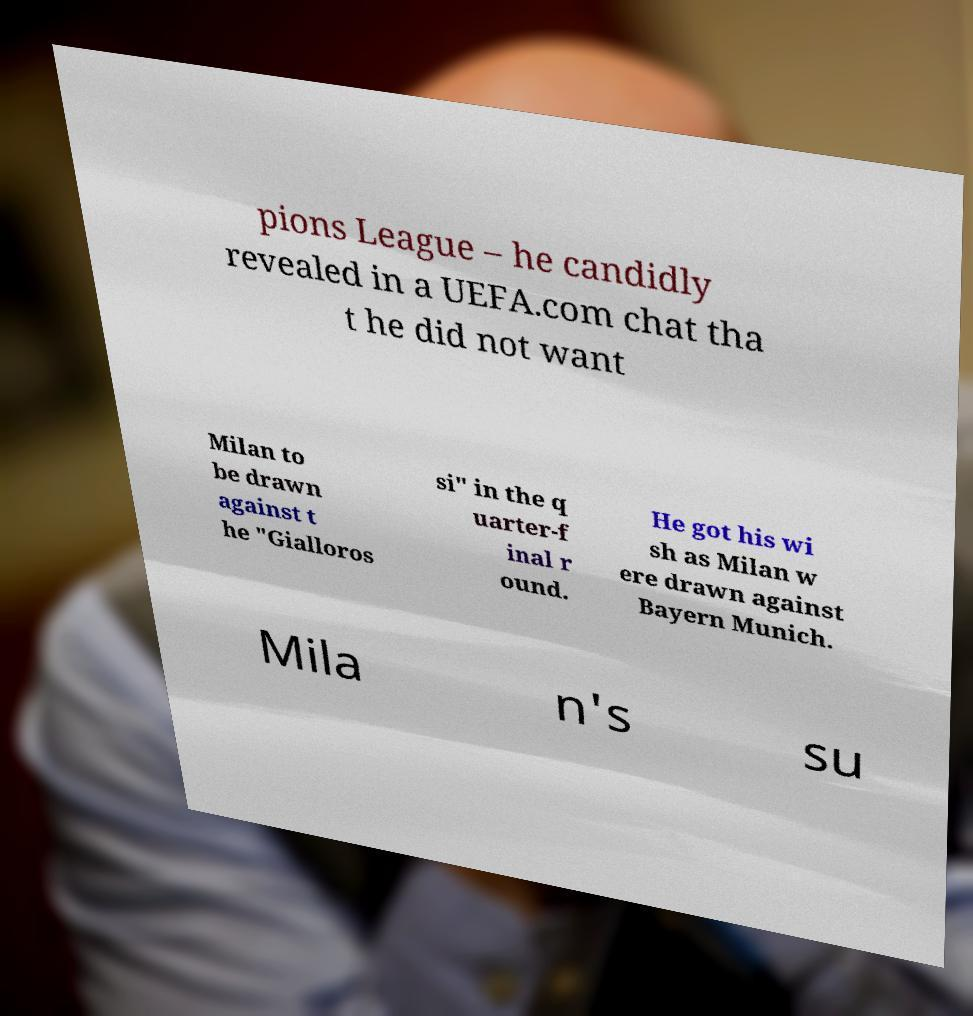There's text embedded in this image that I need extracted. Can you transcribe it verbatim? pions League – he candidly revealed in a UEFA.com chat tha t he did not want Milan to be drawn against t he "Gialloros si" in the q uarter-f inal r ound. He got his wi sh as Milan w ere drawn against Bayern Munich. Mila n's su 